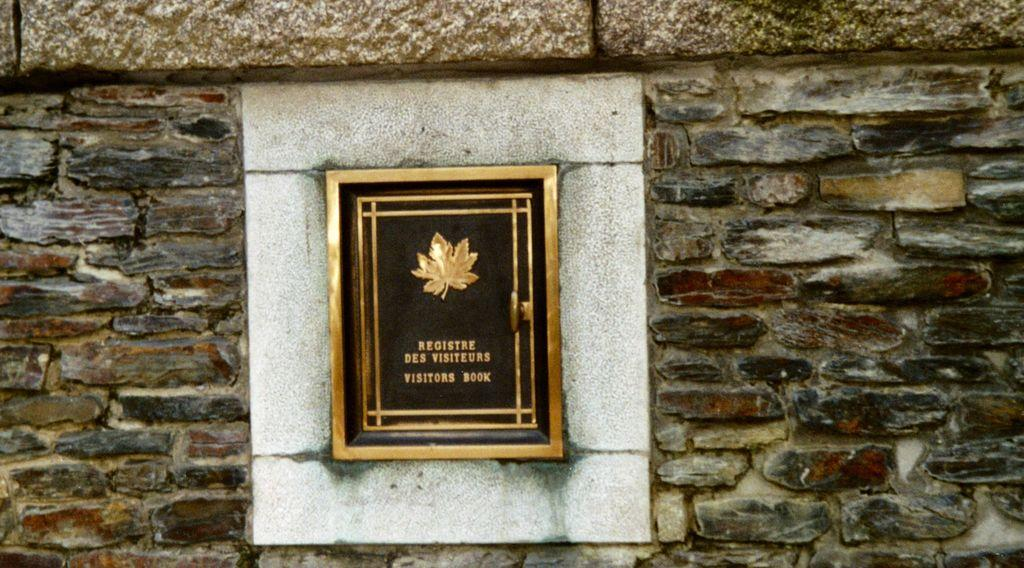What type of frame is in the image? There is a golden leaf frame in the image. Where is the frame located? The frame is fixed in a brick wall. What is written on the frame? The words "Visitor book" are written on the frame. How many fish are swimming in the frame in the image? There are no fish present in the image; it features a golden leaf frame with the words "Visitor book" written on it. 